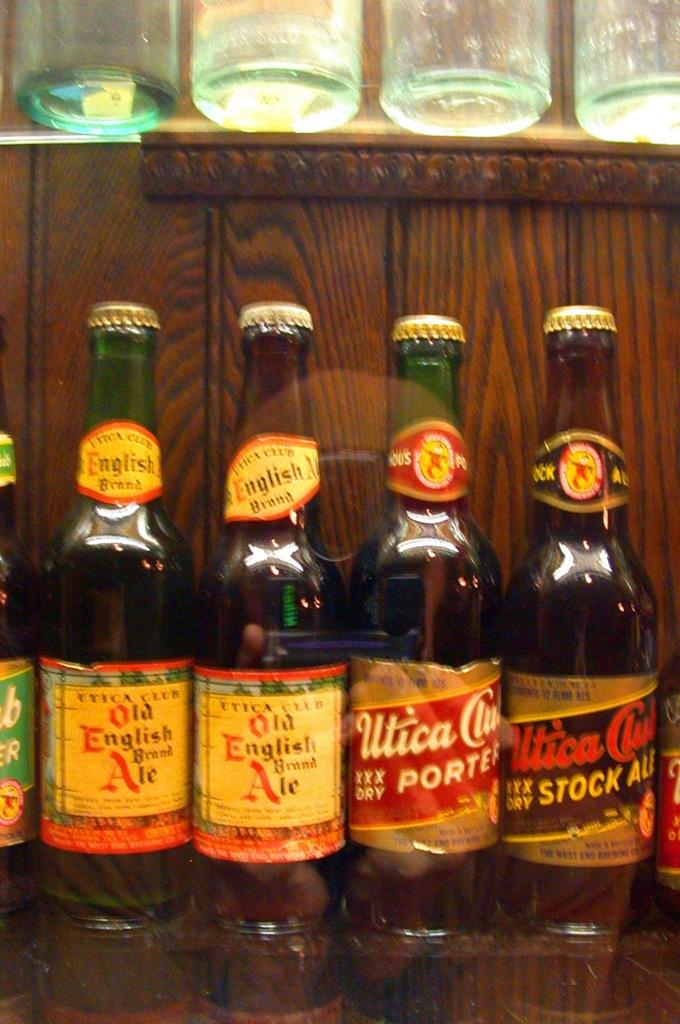What type of beverage containers are in the image? There are wine bottles in the image. Where are the wine bottles located? The wine bottles are on a wooden table. How far away is the throne from the wine bottles in the image? There is no throne present in the image, so it is not possible to determine the distance between the wine bottles and a throne. 